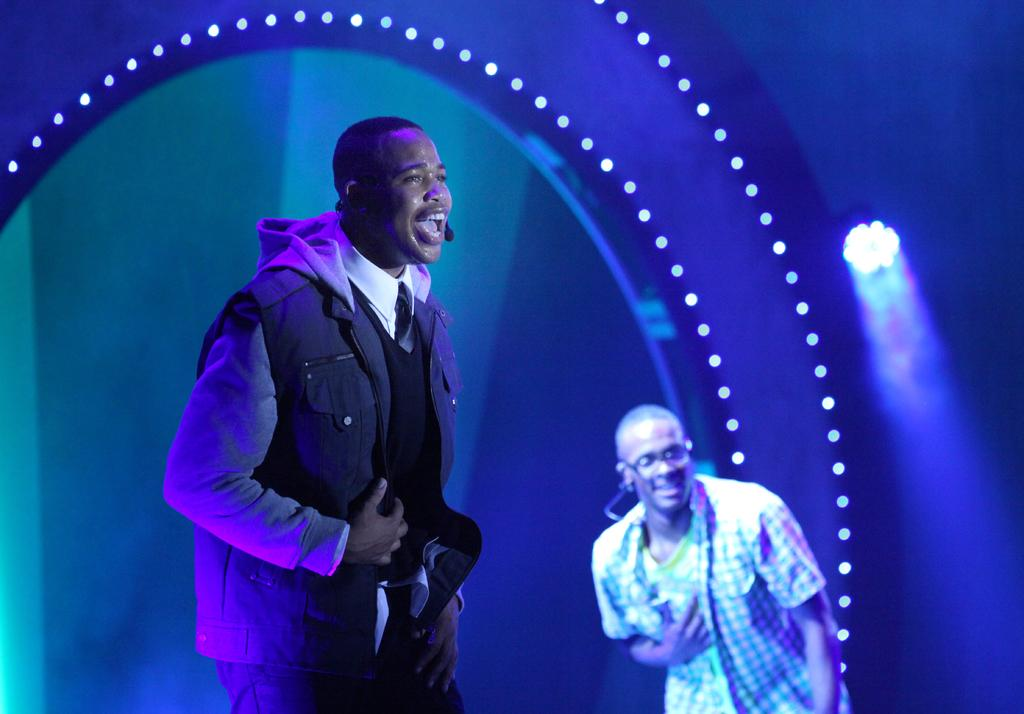What is the main subject of the image? There is a man standing in the image. Can you describe the man's surroundings? There is another man next to the first man. What can be seen in the background of the image? There are lights visible in the background of the image. What type of rock is the man climbing in the image? There is no rock or climbing activity present in the image; it features two men standing next to each other. 